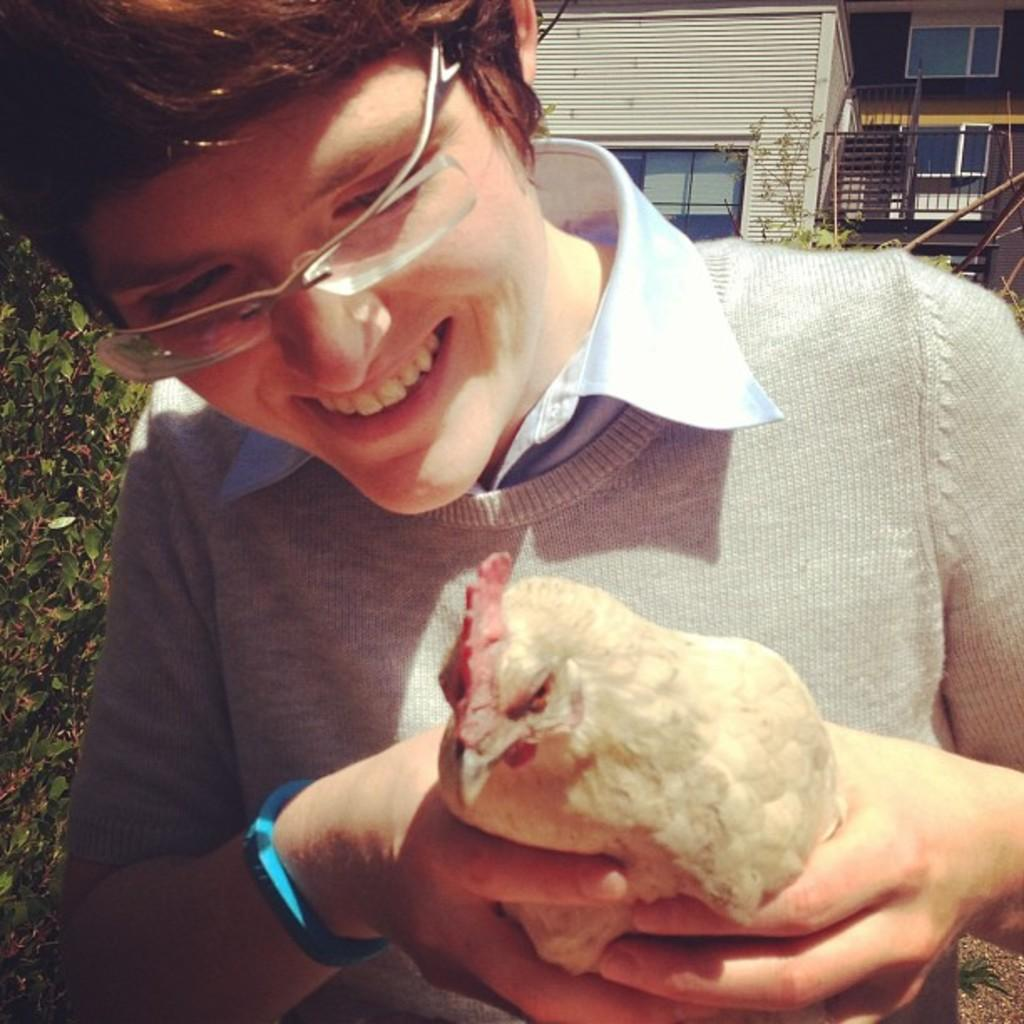What is the person in the image doing? The person is standing in the image and smiling. What is the person holding in their hands? The person is holding a hen in their hands. What can be seen in the background of the image? There is a building and trees in the background of the image. What type of circle is being drawn by the farmer in the image? There is no farmer present in the image, and no one is drawing a circle. 